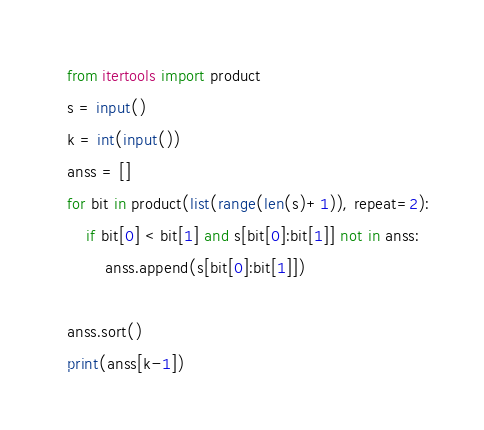Convert code to text. <code><loc_0><loc_0><loc_500><loc_500><_Python_>from itertools import product
s = input()
k = int(input())
anss = []
for bit in product(list(range(len(s)+1)), repeat=2):
    if bit[0] < bit[1] and s[bit[0]:bit[1]] not in anss:
        anss.append(s[bit[0]:bit[1]])

anss.sort()
print(anss[k-1])
</code> 